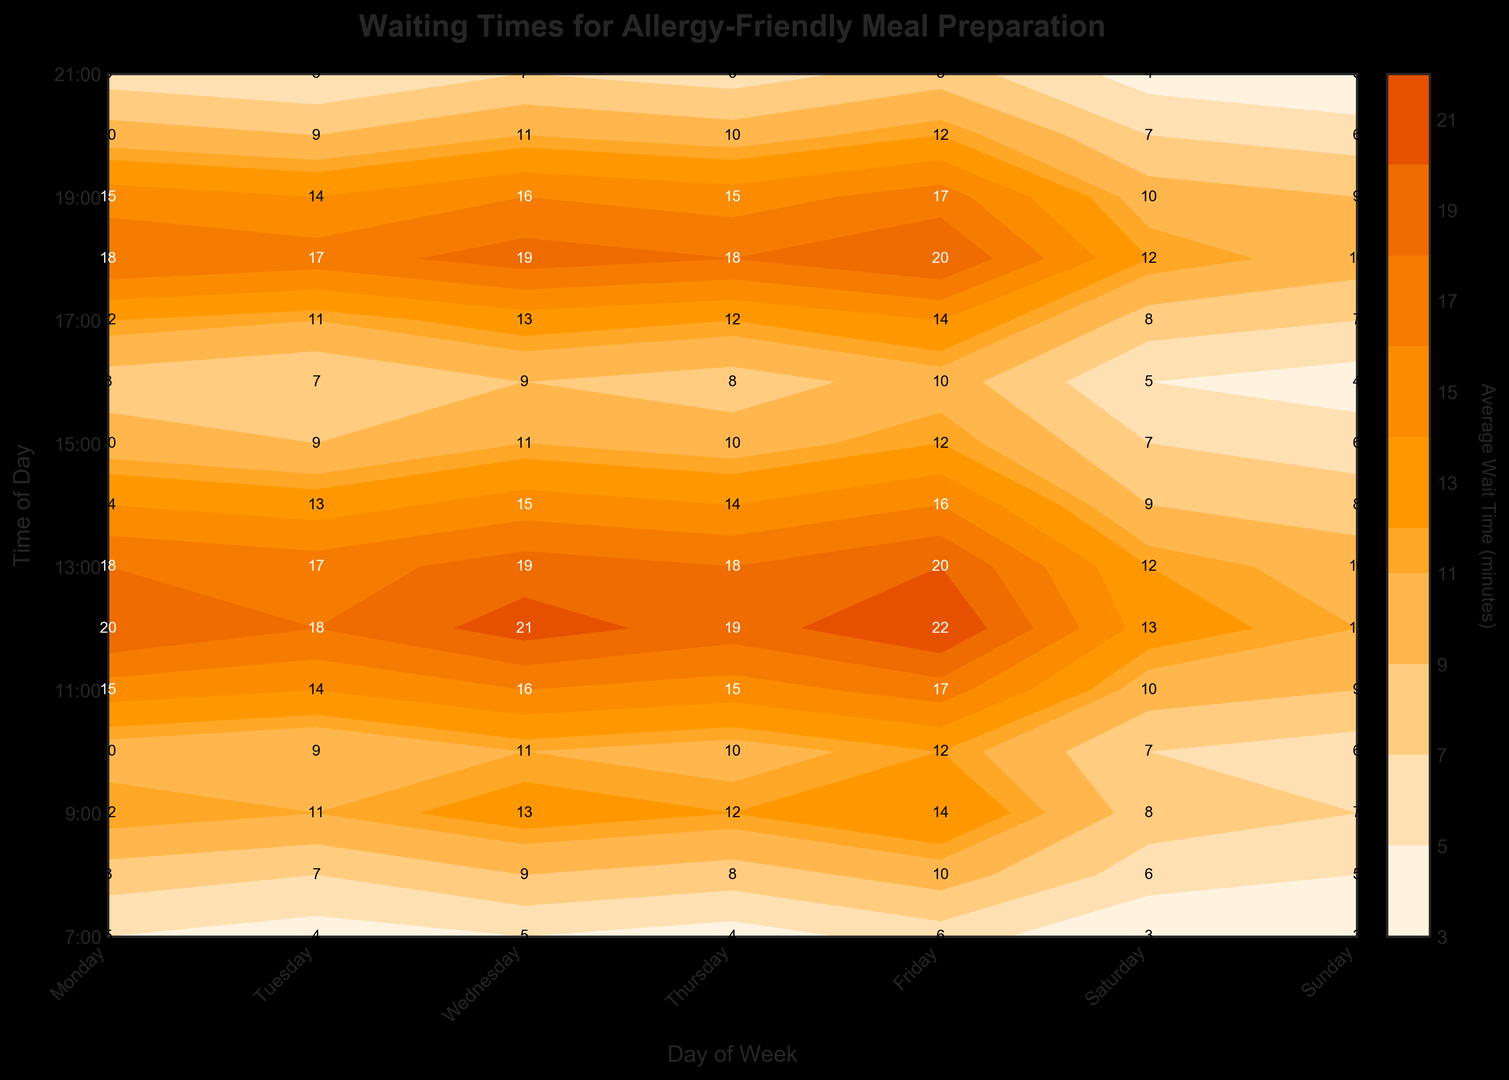What is the approximate waiting time for an allergy-friendly meal on Wednesday at 9:00 AM? First, locate the time of 9:00 AM on the y-axis and follow it horizontally until it intersects with the Wednesday column. The contour plot indicates the wait time is around 13 minutes.
Answer: 13 minutes What day has the shortest average waiting time at 12:00 PM? To find this, look at the row corresponding to 12:00 PM and identify the lowest value among all the days. Sunday has the shortest waiting time, with 11 minutes.
Answer: Sunday During which time period on Friday, is the average waiting time the highest? Look along the Friday column to find the highest value. The period with the highest average waiting time is 12:00 PM, with a wait time of 22 minutes.
Answer: 12:00 PM How does the waiting time on Saturdays at 5:00 PM compare to Sundays at the same time? Compare the wait times for 5:00 PM on Saturday and Sunday. The wait time on Saturday is 8 minutes, while on Sunday, it is 7 minutes.
Answer: Saturday is higher What is the trend in waiting times from 8:00 AM to 12:00 PM on Tuesday? Examine the values from 8:00 AM to 12:00 PM on Tuesday. The times are 7, 11, 14, 9, 18. The trend shows an initial increase peaking at 11:00 AM before slightly decreasing at 12:00 PM.
Answer: Generally increasing Which day has the highest wait time at 8:00 AM? Look at the row for 8:00 AM and identify the highest value among all days. The highest wait time is on Friday, with 10 minutes.
Answer: Friday At what time is the waiting time for allergy-friendly meals the lowest on Monday? Check the Monday column for the smallest value. The smallest value is 5 minutes, and it occurs at 7:00 AM.
Answer: 7:00 AM How do the average waiting times compare between Monday and Tuesday at 6:00 PM? Check the values for 6:00 PM in both columns. Monday has a wait time of 18 minutes, while Tuesday has 17 minutes.
Answer: Monday is higher What is the average wait time across all days at 1:00 PM? Read the wait times for 1:00 PM for each day. The values are 18, 17, 19, 18, 20, 12, and 10. Sum these values: 18+17+19+18+20+12+10 = 114. Divide by 7 to get the average: 114/7 = 16.3.
Answer: 16.3 minutes 